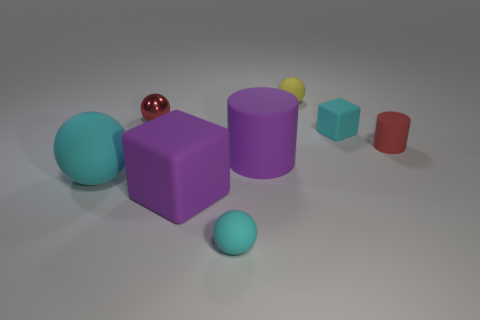Subtract 1 balls. How many balls are left? 3 Add 1 large purple rubber cylinders. How many objects exist? 9 Subtract all cubes. How many objects are left? 6 Subtract 0 brown cylinders. How many objects are left? 8 Subtract all tiny yellow spheres. Subtract all small gray things. How many objects are left? 7 Add 6 small red metallic objects. How many small red metallic objects are left? 7 Add 4 large green shiny cylinders. How many large green shiny cylinders exist? 4 